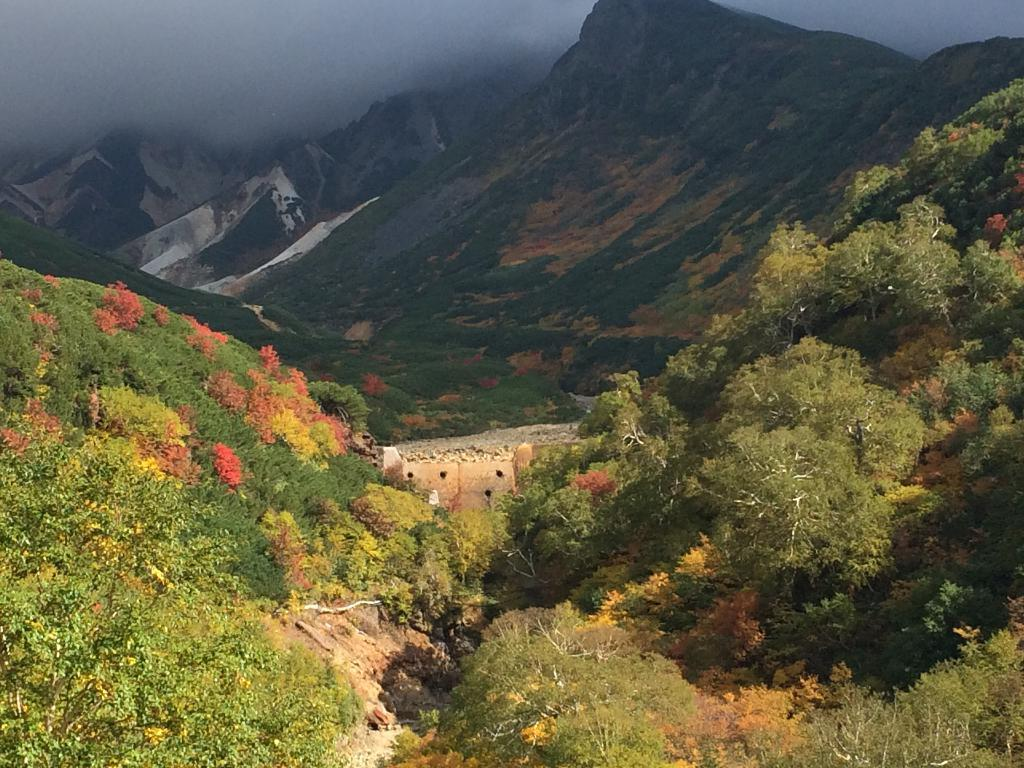What type of ground covering can be seen in the image? The ground is covered with grass. What other types of vegetation are present in the image? There are plants and many trees in the image. What can be seen in the distance in the background of the image? There are mountains visible in the background of the image. What type of roof can be seen on the trees in the image? There are no roofs present on the trees in the image, as trees do not have roofs. 